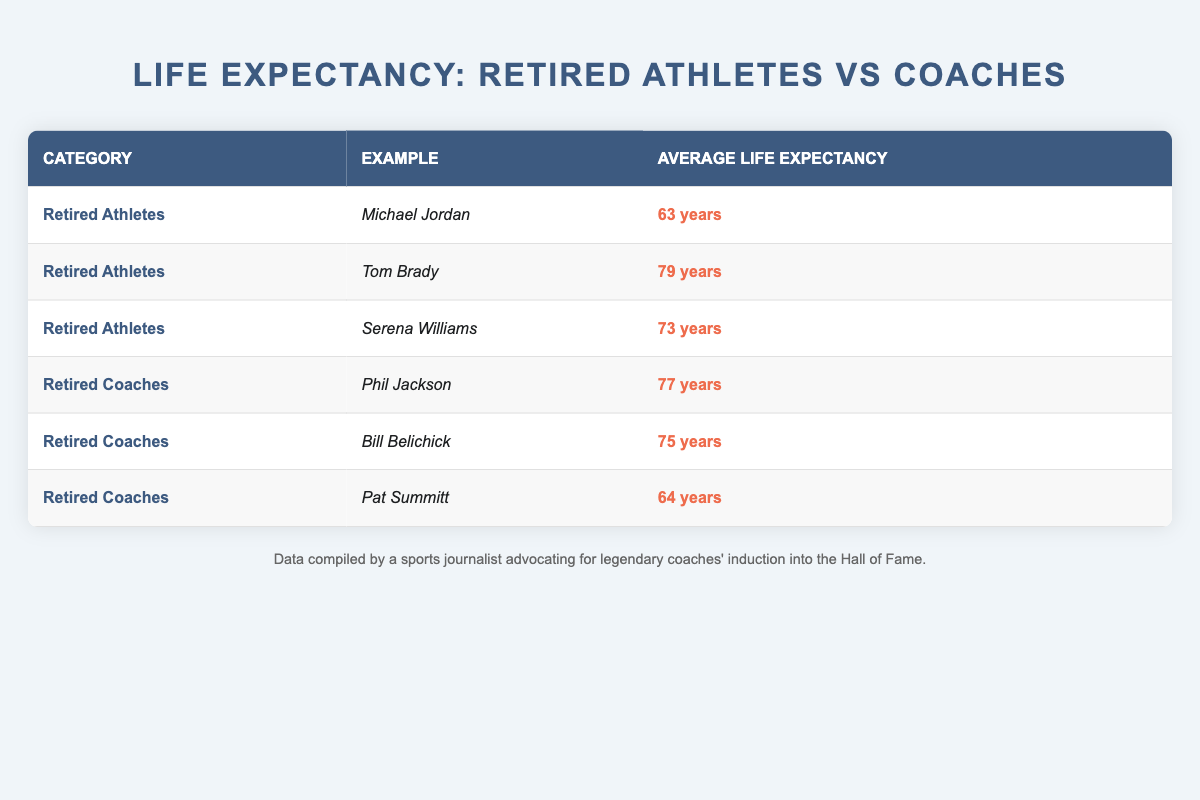What is the average life expectancy of retired athletes? To find the average life expectancy of retired athletes, we look at the three examples provided: Michael Jordan (63 years), Tom Brady (79 years), and Serena Williams (73 years). We sum these values (63 + 79 + 73 = 215) and divide by the number of athletes (3), so the average is 215 / 3 = 71.67 years, which can be approximated as 72 years.
Answer: 72 years Which retired coach has the highest life expectancy? By examining the life expectancy values for retired coaches, we see Phil Jackson (77 years), Bill Belichick (75 years), and Pat Summitt (64 years). Phil Jackson has the highest value at 77 years.
Answer: Phil Jackson Is the average life expectancy of retired athletes higher than that of retired coaches? First, calculate the average life expectancy for retired coaches: Phil Jackson (77 years), Bill Belichick (75 years), and Pat Summitt (64 years), summing these gives 77 + 75 + 64 = 216, which divided by 3 is 72 years. The average for retired athletes is previously calculated as approximately 72 years, hence they are equal.
Answer: No What is the combined life expectancy of all the retired athletes listed? The life expectancy values for retired athletes are Michael Jordan (63 years), Tom Brady (79 years), and Serena Williams (73 years). Adding these gives us 63 + 79 + 73 = 215 years.
Answer: 215 years Are there more retired athletes with an average life expectancy above 70 years than retired coaches? The retired athletes listed are Michael Jordan (63 years), Tom Brady (79 years), and Serena Williams (73 years). Of these, Tom Brady and Serena Williams have life expectancies above 70 years, so that's 2 athletes. The retired coaches are Phil Jackson (77 years), Bill Belichick (75 years), and Pat Summitt (64 years). Only Phil Jackson and Bill Belichick have life expectancies above 70 years, giving us 2 coaches. Therefore, the number of athletes (2) is equal to the number of coaches (2).
Answer: No What is the difference in average life expectancy between the categories of retired athletes and retired coaches? The average life expectancy of retired athletes is approximately 72 years, and that of retired coaches is calculated as 72 years as well. The difference is therefore 72 - 72 = 0 years.
Answer: 0 years 